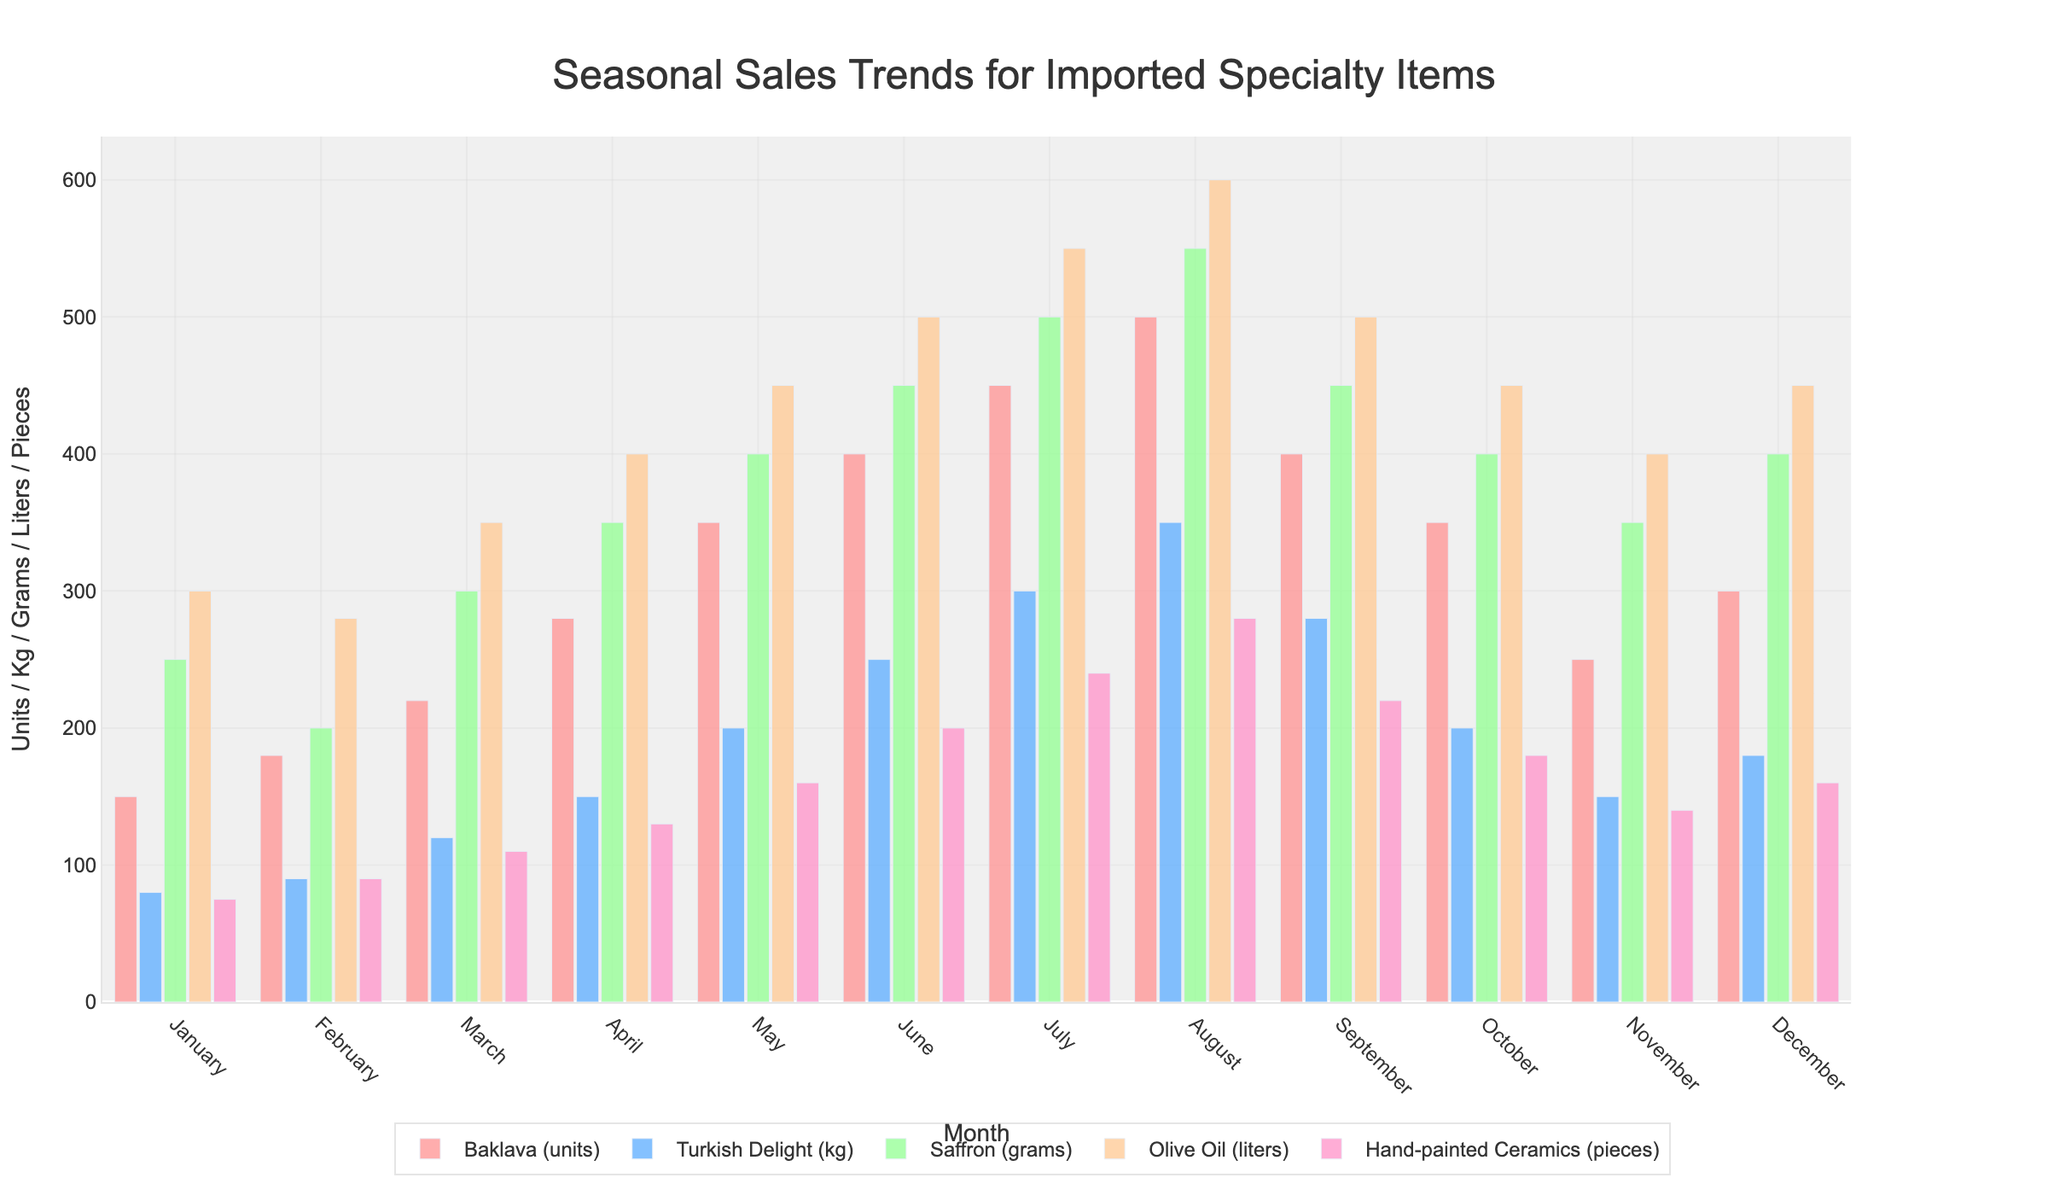What is the highest number of Baklava units sold in a month? Check the figure for the month with the tallest bar for Baklava, which is colored in red. August has the highest bar with 500 units.
Answer: 500 Which month had the lowest sales for Hand-painted Ceramics? Look for the shortest blue bar corresponding to Hand-painted Ceramics. January has the shortest bar with 75 pieces.
Answer: January What are the total sales for Saffron in the first three months? (Compositional) Sum the values of the orange bars for Saffron in January, February, and March. 250 grams + 200 grams + 300 grams = 750 grams.
Answer: 750 grams During which month were Turkish Delight sales exactly 200 kg? Identify the month where the green bar height reaches 200 kg for Turkish Delight. This occurs in May.
Answer: May What was the difference in sales units of Baklava between July and January? (Comparison/Compositional) Look at the red bars for July and January, which are 450 units and 150 units respectively. Calculate 450 - 150 = 300 units difference.
Answer: 300 units How do the sales of Olive Oil change from March to April? (Comparison) Compare the heights of the grey bars for Olive Oil in March and April. March sold 350 liters and April sold 400 liters. An increase of 50 liters.
Answer: Increased by 50 liters Which product showed the most consistent sales throughout the year? Compare the variation in bar heights for each product and observe which product has the bars most similar in height across all months. Olive Oil shows the least variation.
Answer: Olive Oil In which month were total sales (combined) the highest? (Compositional) Sum the heights of all bars across each month to find the highest total. August has the tallest combined bars with totals adding up to the highest value.
Answer: August How do the sales of Turkish Delight in September compare to those in June? (Comparison) Compare the green bars for Turkish Delight in September (280 kg) and June (250 kg). September has higher sales by 30 kg.
Answer: September What is the average monthly sales for Hand-painted Ceramics in the first half of the year? (Compositional) Average the values of the purple bars for Hand-painted Ceramics from January to June. (75 + 90 + 110 + 130 + 160 + 200) / 6 = 127.5 pieces.
Answer: 127.5 pieces 